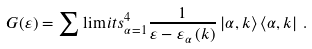<formula> <loc_0><loc_0><loc_500><loc_500>G ( \varepsilon ) = \sum \lim i t s _ { \alpha = 1 } ^ { 4 } \frac { 1 } { \varepsilon - \varepsilon _ { \alpha } \left ( k \right ) } \left | \alpha , k \right \rangle \left \langle \alpha , k \right | \, .</formula> 